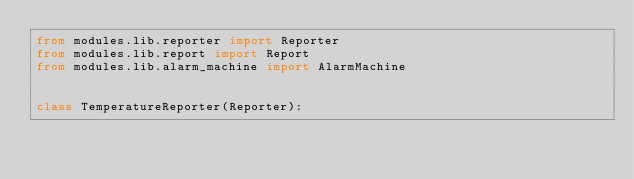<code> <loc_0><loc_0><loc_500><loc_500><_Python_>from modules.lib.reporter import Reporter
from modules.lib.report import Report
from modules.lib.alarm_machine import AlarmMachine


class TemperatureReporter(Reporter):</code> 